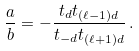<formula> <loc_0><loc_0><loc_500><loc_500>\frac { a } { b } = - \frac { t _ { d } t _ { ( \ell - 1 ) d } } { t _ { - d } t _ { ( \ell + 1 ) d } } \, .</formula> 